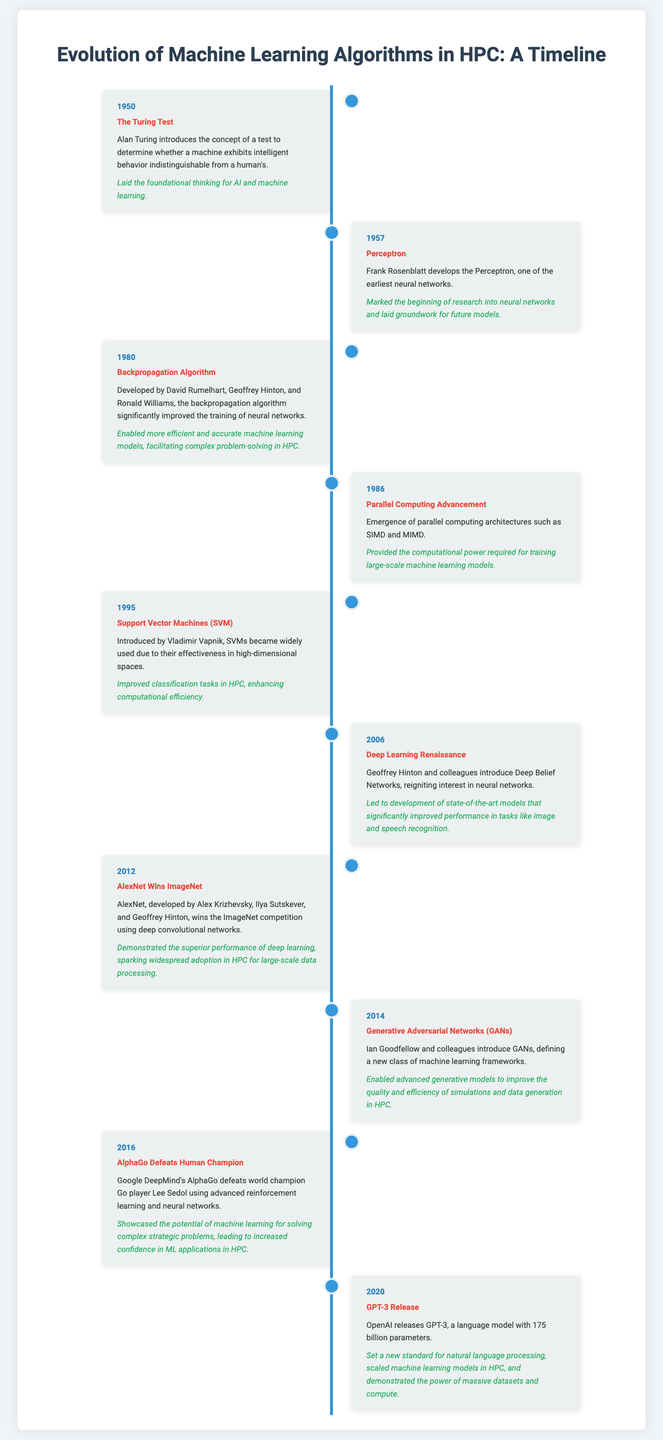What year was the Turing Test introduced? The Turing Test was introduced in the year 1950, as noted in the timeline.
Answer: 1950 Who developed the Perceptron? The Perceptron was developed by Frank Rosenblatt, as mentioned in the document.
Answer: Frank Rosenblatt What significant algorithm was developed in 1980? The significant algorithm developed in 1980 is the Backpropagation Algorithm, as stated in the timeline.
Answer: Backpropagation Algorithm What impact did AlexNet winning ImageNet have on HPC? AlexNet winning ImageNet demonstrated the superior performance of deep learning, which sparked widespread adoption in HPC for large-scale data processing.
Answer: Widespread adoption What is the main focus of Generative Adversarial Networks (GANs)? The main focus of GANs is to enable advanced generative models to improve the quality and efficiency of simulations and data generation in HPC.
Answer: Advanced generative models In what year did AlphaGo defeat a human champion? AlphaGo defeated a human champion in the year 2016, as documented in the timeline.
Answer: 2016 What year was GPT-3 released? GPT-3 was released in 2020, according to the timeline.
Answer: 2020 Which model introduced a significant improvement in natural language processing? GPT-3 introduced a significant improvement in natural language processing, as detailed in the document.
Answer: GPT-3 How did the Backpropagation Algorithm impact neural networks? The Backpropagation Algorithm enabled more efficient and accurate machine learning models, thus facilitating complex problem-solving in HPC.
Answer: Complex problem-solving 